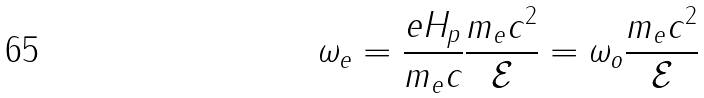<formula> <loc_0><loc_0><loc_500><loc_500>\omega _ { e } = \frac { e H _ { p } } { m _ { e } c } \frac { m _ { e } c ^ { 2 } } { \mathcal { E } } = \omega _ { o } \frac { m _ { e } c ^ { 2 } } { \mathcal { E } }</formula> 